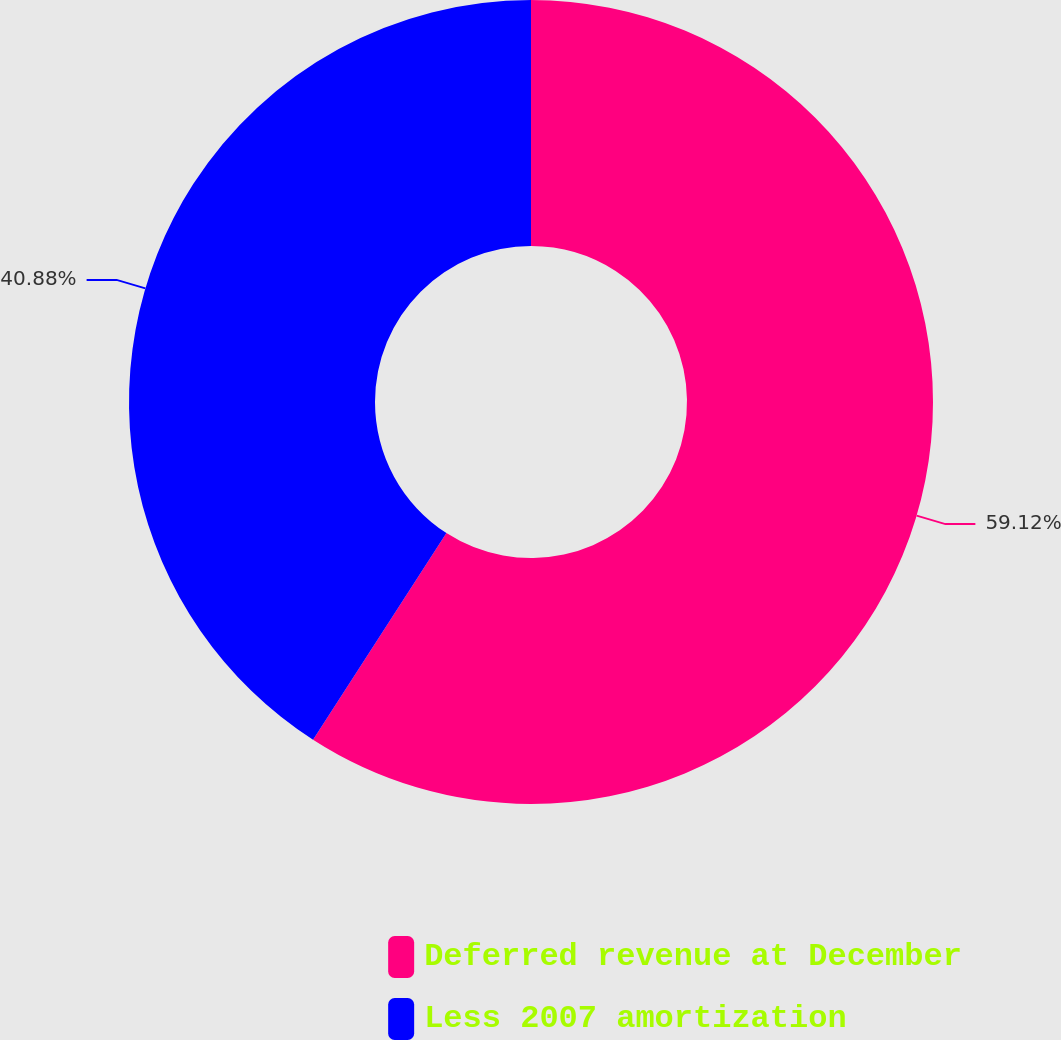Convert chart to OTSL. <chart><loc_0><loc_0><loc_500><loc_500><pie_chart><fcel>Deferred revenue at December<fcel>Less 2007 amortization<nl><fcel>59.12%<fcel>40.88%<nl></chart> 